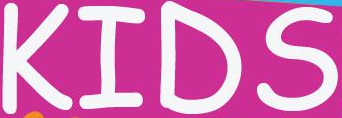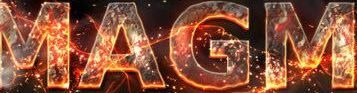Read the text from these images in sequence, separated by a semicolon. KIDS; MAGM 